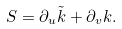Convert formula to latex. <formula><loc_0><loc_0><loc_500><loc_500>S = \partial _ { u } \tilde { k } + \partial _ { v } k .</formula> 